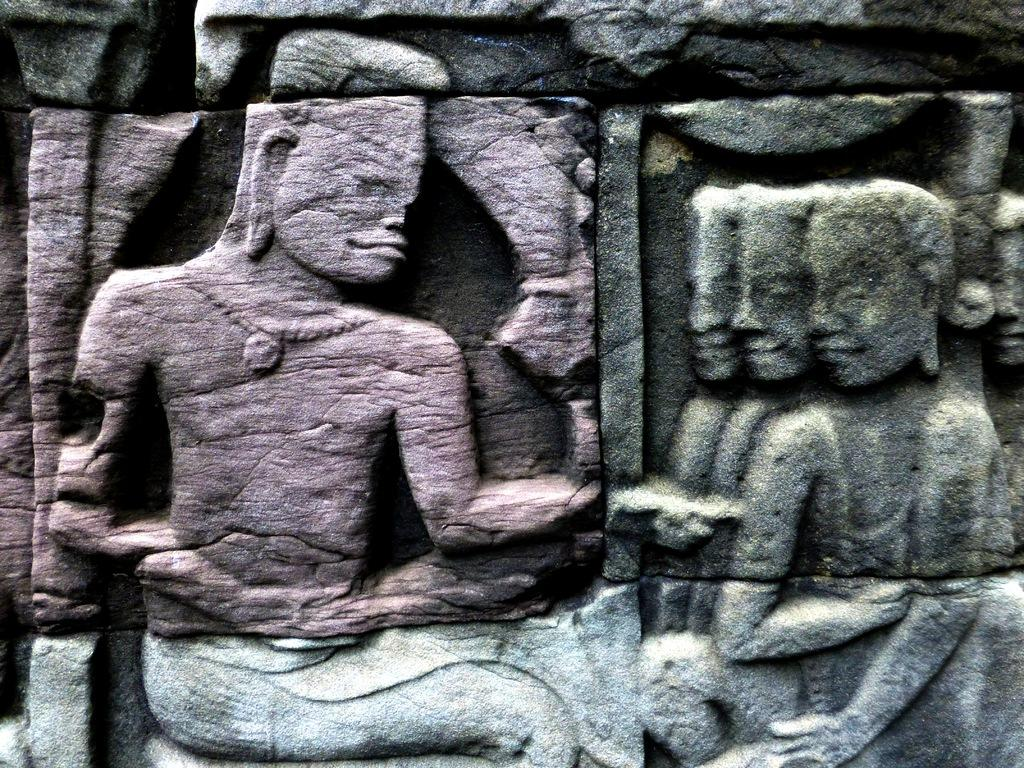What is depicted on the stone in the image? There are carvings of people on the stone in the image. Can you describe the carvings in more detail? The carvings are of people, but the specific details of their appearance or actions cannot be determined from the image alone. What type of stamp can be seen on the legs of the people in the image? There are no stamps or legs visible in the image; it only shows carvings of people on a stone. 